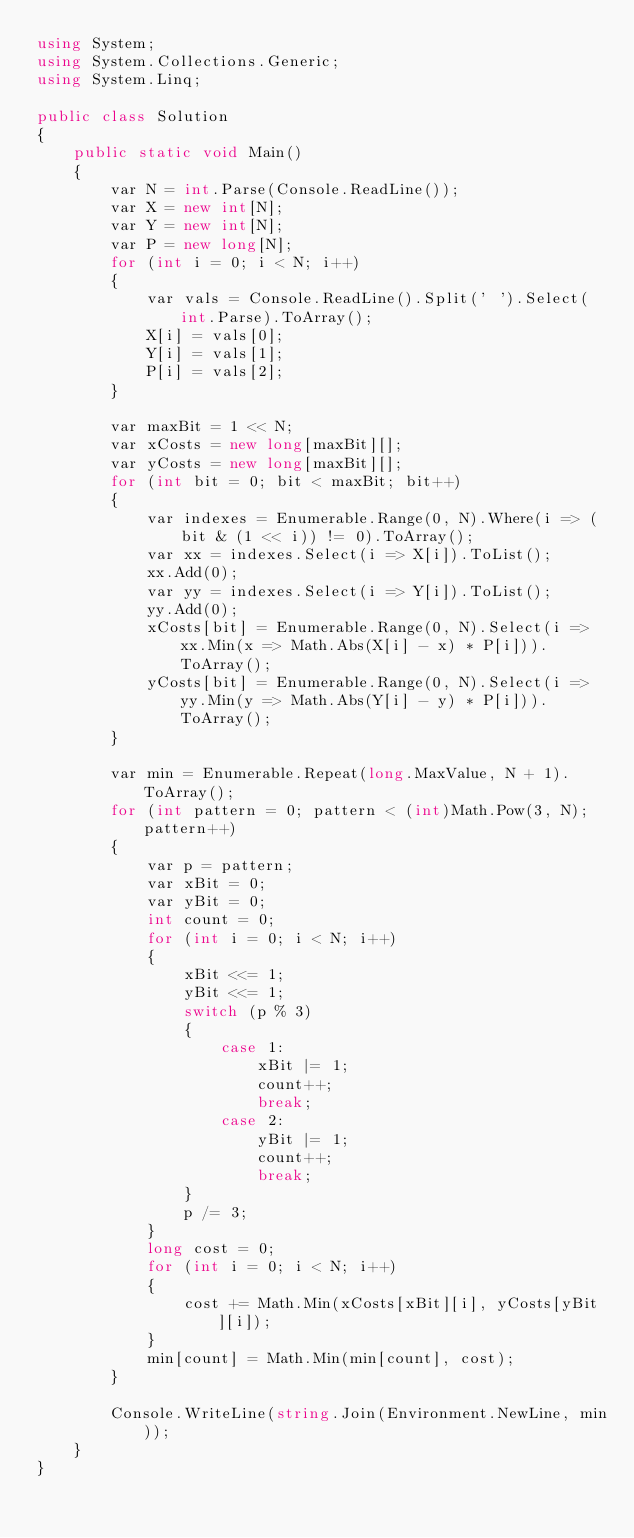<code> <loc_0><loc_0><loc_500><loc_500><_C#_>using System;
using System.Collections.Generic;
using System.Linq;

public class Solution
{
    public static void Main()
    {
        var N = int.Parse(Console.ReadLine());
        var X = new int[N];
        var Y = new int[N];
        var P = new long[N];
        for (int i = 0; i < N; i++)
        {
            var vals = Console.ReadLine().Split(' ').Select(int.Parse).ToArray();
            X[i] = vals[0];
            Y[i] = vals[1];
            P[i] = vals[2];
        }

        var maxBit = 1 << N;
        var xCosts = new long[maxBit][];
        var yCosts = new long[maxBit][];
        for (int bit = 0; bit < maxBit; bit++)
        {
            var indexes = Enumerable.Range(0, N).Where(i => (bit & (1 << i)) != 0).ToArray();
            var xx = indexes.Select(i => X[i]).ToList();
            xx.Add(0);
            var yy = indexes.Select(i => Y[i]).ToList();
            yy.Add(0);
            xCosts[bit] = Enumerable.Range(0, N).Select(i => xx.Min(x => Math.Abs(X[i] - x) * P[i])).ToArray();
            yCosts[bit] = Enumerable.Range(0, N).Select(i => yy.Min(y => Math.Abs(Y[i] - y) * P[i])).ToArray();
        }

        var min = Enumerable.Repeat(long.MaxValue, N + 1).ToArray();
        for (int pattern = 0; pattern < (int)Math.Pow(3, N); pattern++)
        {
            var p = pattern;
            var xBit = 0;
            var yBit = 0;
            int count = 0;
            for (int i = 0; i < N; i++)
            {
                xBit <<= 1;
                yBit <<= 1;
                switch (p % 3)
                {
                    case 1:
                        xBit |= 1;
                        count++;
                        break;
                    case 2:
                        yBit |= 1;
                        count++;
                        break;
                }
                p /= 3;
            }
            long cost = 0;
            for (int i = 0; i < N; i++)
            {
                cost += Math.Min(xCosts[xBit][i], yCosts[yBit][i]);
            }
            min[count] = Math.Min(min[count], cost);
        }

        Console.WriteLine(string.Join(Environment.NewLine, min));
    }
}</code> 